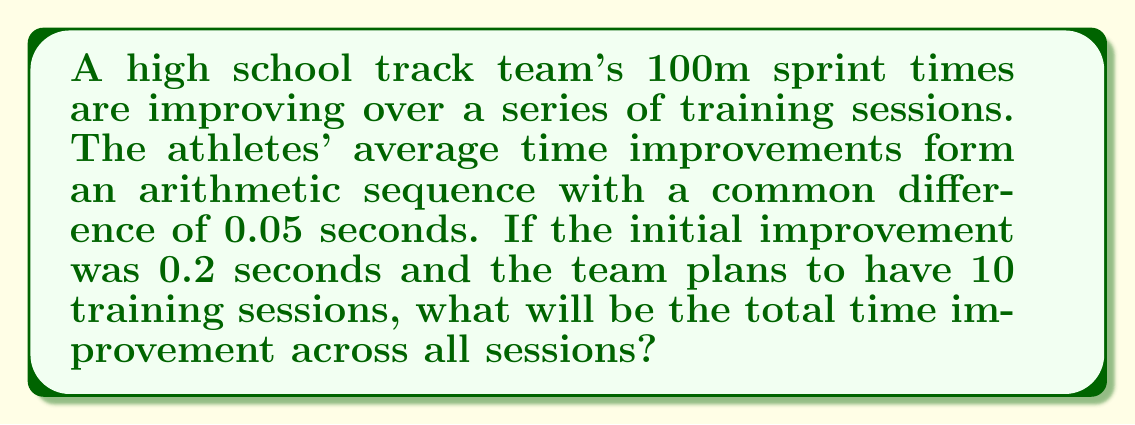Solve this math problem. Let's approach this step-by-step:

1) We have an arithmetic sequence where:
   - First term, $a_1 = 0.2$ seconds
   - Common difference, $d = 0.05$ seconds
   - Number of terms, $n = 10$ (10 training sessions)

2) We need to find the sum of this arithmetic sequence. The formula for the sum of an arithmetic sequence is:

   $$ S_n = \frac{n}{2}(a_1 + a_n) $$

   where $a_n$ is the last term of the sequence.

3) To find $a_n$, we can use the arithmetic sequence formula:
   
   $$ a_n = a_1 + (n-1)d $$

4) Substituting our values:

   $$ a_{10} = 0.2 + (10-1)(0.05) = 0.2 + (9)(0.05) = 0.2 + 0.45 = 0.65 $$

5) Now we can use the sum formula:

   $$ S_{10} = \frac{10}{2}(0.2 + 0.65) = 5(0.85) = 4.25 $$

Therefore, the total time improvement across all 10 sessions will be 4.25 seconds.
Answer: 4.25 seconds 